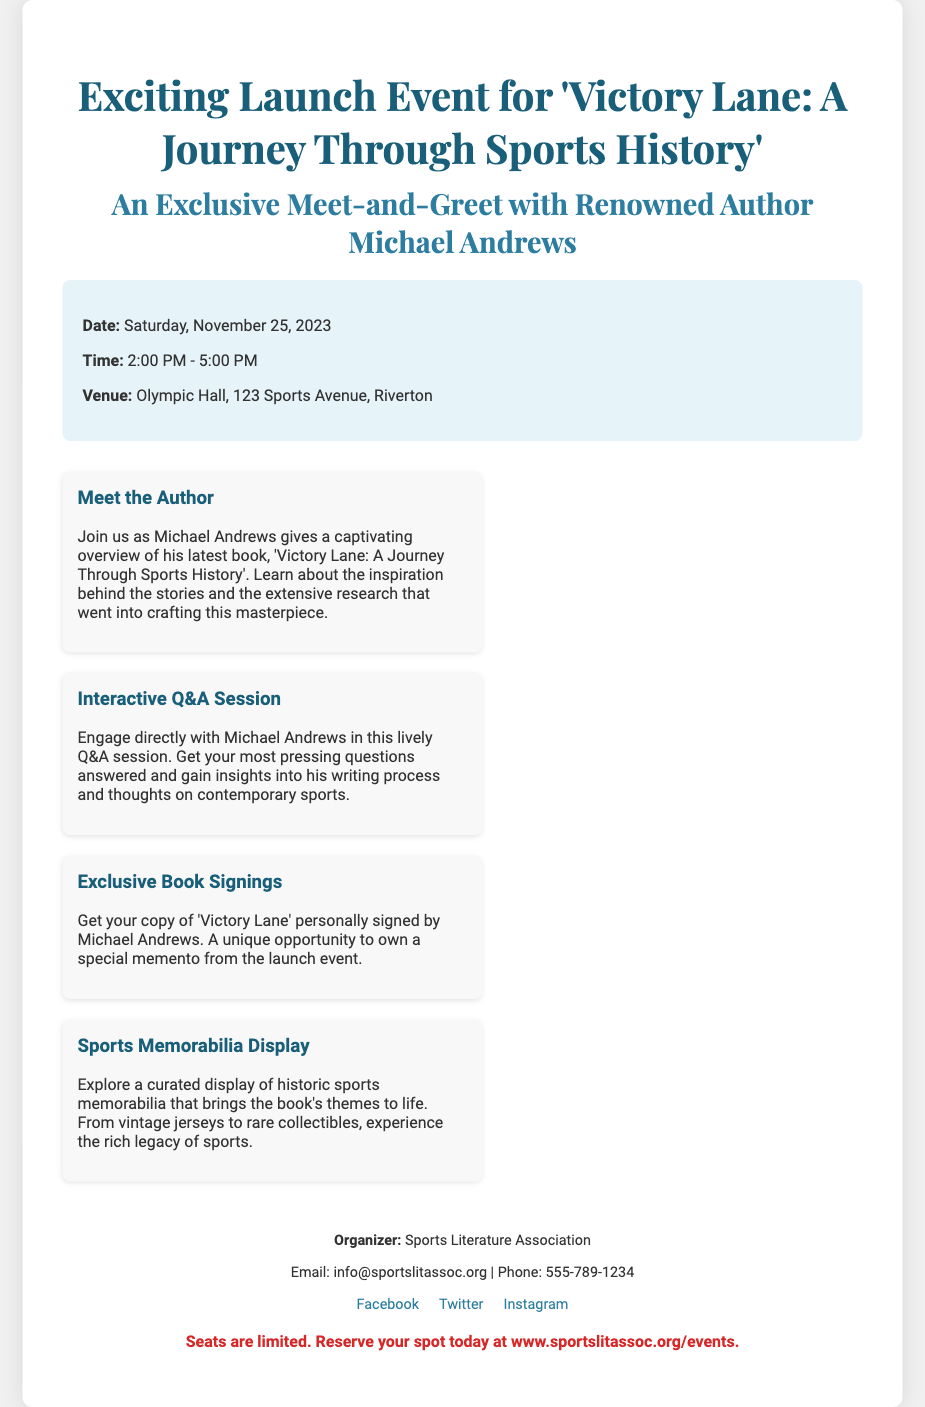What is the title of the book being launched? The title of the book is specified in the poster.
Answer: 'Victory Lane: A Journey Through Sports History' Who is the author of the book? The author's name is provided in the poster.
Answer: Michael Andrews What date is the launch event scheduled for? The date of the event is explicitly mentioned.
Answer: Saturday, November 25, 2023 What is the venue for the event? The venue details are included in the event information.
Answer: Olympic Hall, 123 Sports Avenue, Riverton What type of session can attendees engage in with the author? The poster describes a specific type of interaction with the author.
Answer: Interactive Q&A Session How long is the launch event scheduled to last? The duration of the event can be inferred from the start and end times.
Answer: 3 hours What opportunity is offered regarding book signings? The poster highlights a specific feature related to book signings.
Answer: Exclusive Book Signings Which organization is hosting the event? The organizing body is clearly stated in the contact information section.
Answer: Sports Literature Association How can attendees reserve their spots? The method for reserving seats is provided in the note.
Answer: www.sportslitassoc.org/events 